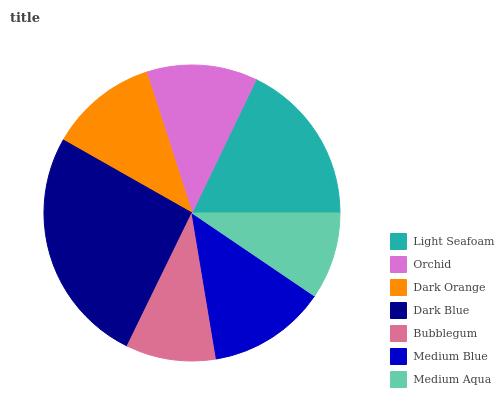Is Medium Aqua the minimum?
Answer yes or no. Yes. Is Dark Blue the maximum?
Answer yes or no. Yes. Is Orchid the minimum?
Answer yes or no. No. Is Orchid the maximum?
Answer yes or no. No. Is Light Seafoam greater than Orchid?
Answer yes or no. Yes. Is Orchid less than Light Seafoam?
Answer yes or no. Yes. Is Orchid greater than Light Seafoam?
Answer yes or no. No. Is Light Seafoam less than Orchid?
Answer yes or no. No. Is Orchid the high median?
Answer yes or no. Yes. Is Orchid the low median?
Answer yes or no. Yes. Is Light Seafoam the high median?
Answer yes or no. No. Is Medium Aqua the low median?
Answer yes or no. No. 